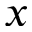Convert formula to latex. <formula><loc_0><loc_0><loc_500><loc_500>x</formula> 